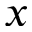Convert formula to latex. <formula><loc_0><loc_0><loc_500><loc_500>x</formula> 